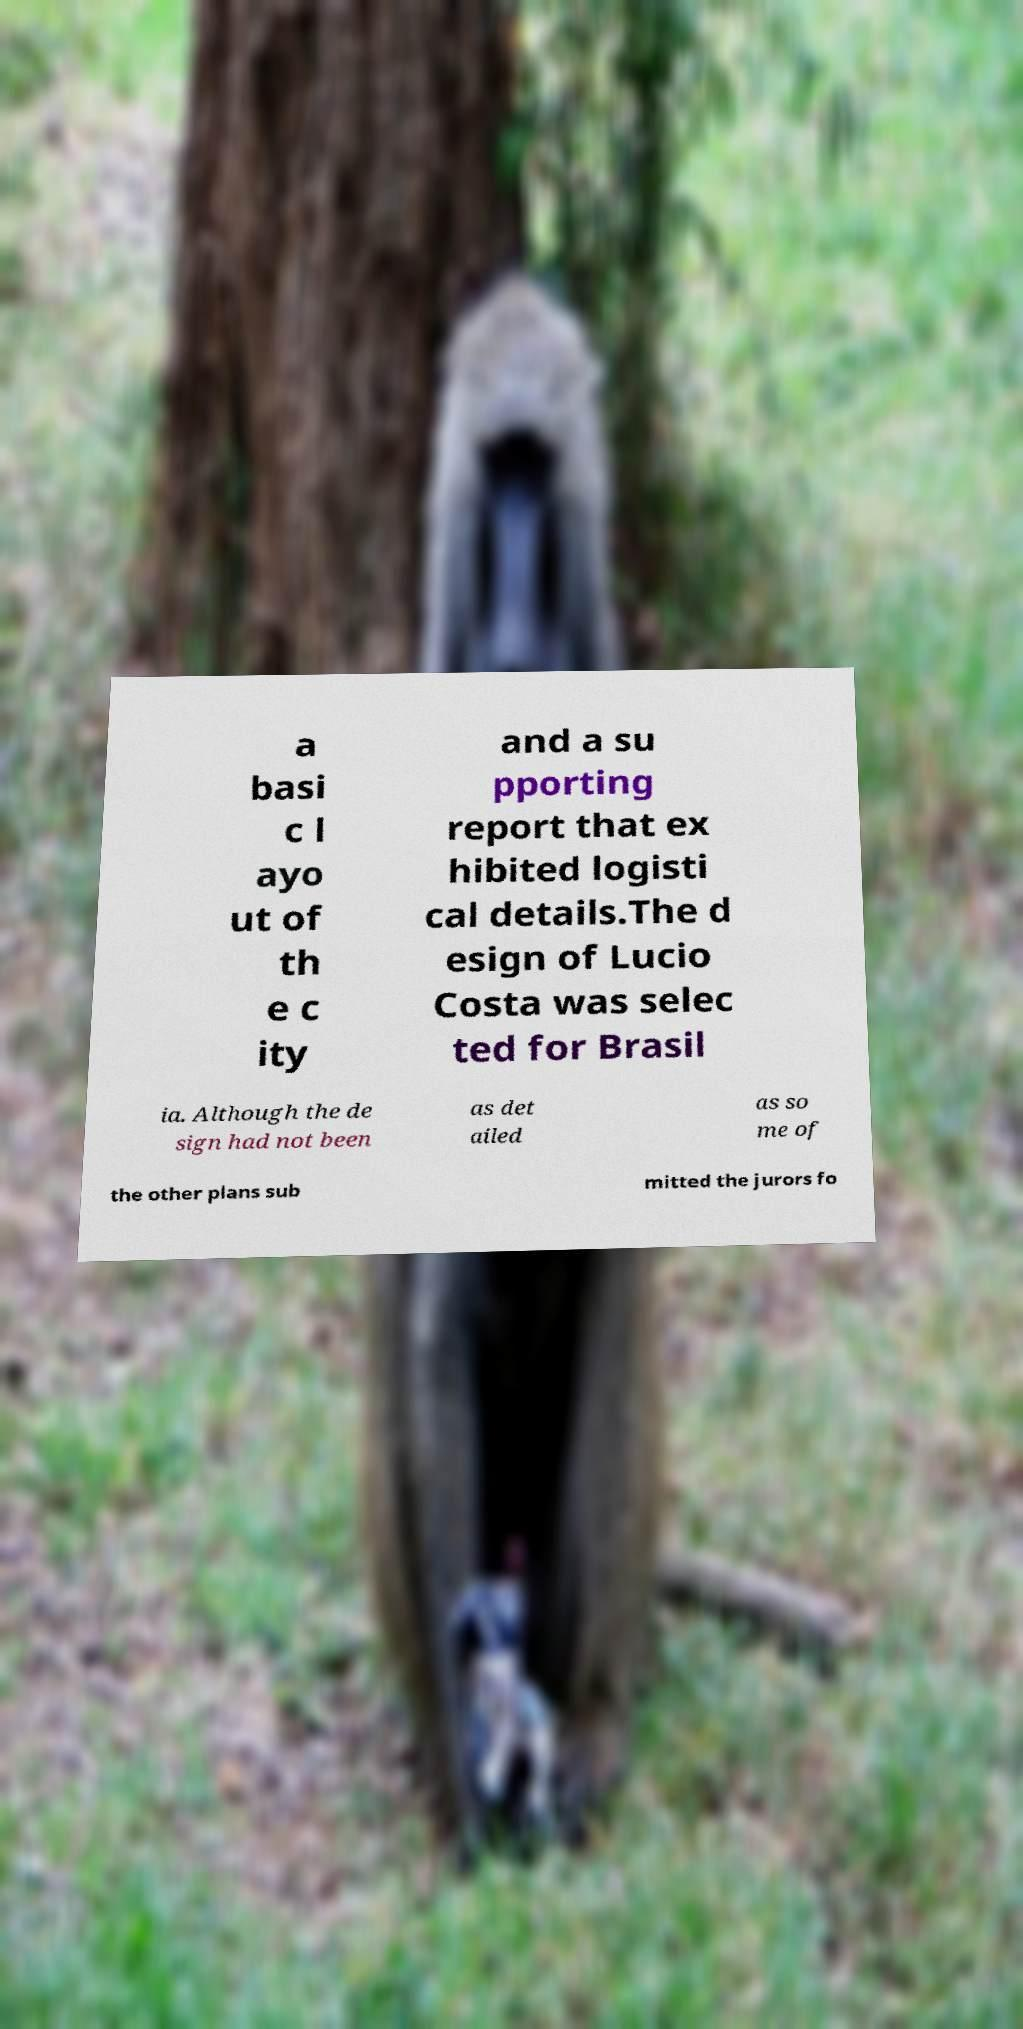I need the written content from this picture converted into text. Can you do that? a basi c l ayo ut of th e c ity and a su pporting report that ex hibited logisti cal details.The d esign of Lucio Costa was selec ted for Brasil ia. Although the de sign had not been as det ailed as so me of the other plans sub mitted the jurors fo 